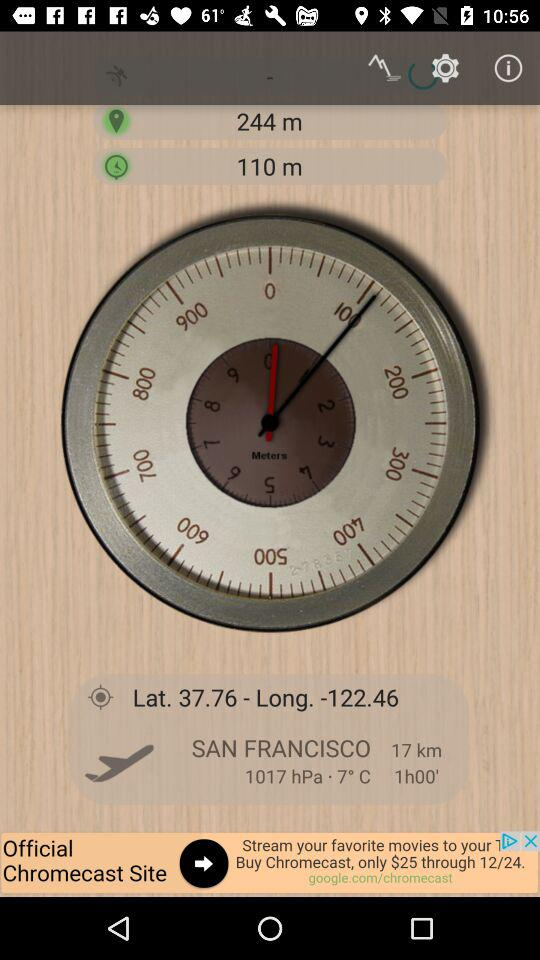What is the temperature in San Francisco? The temperature is 7 °C. 